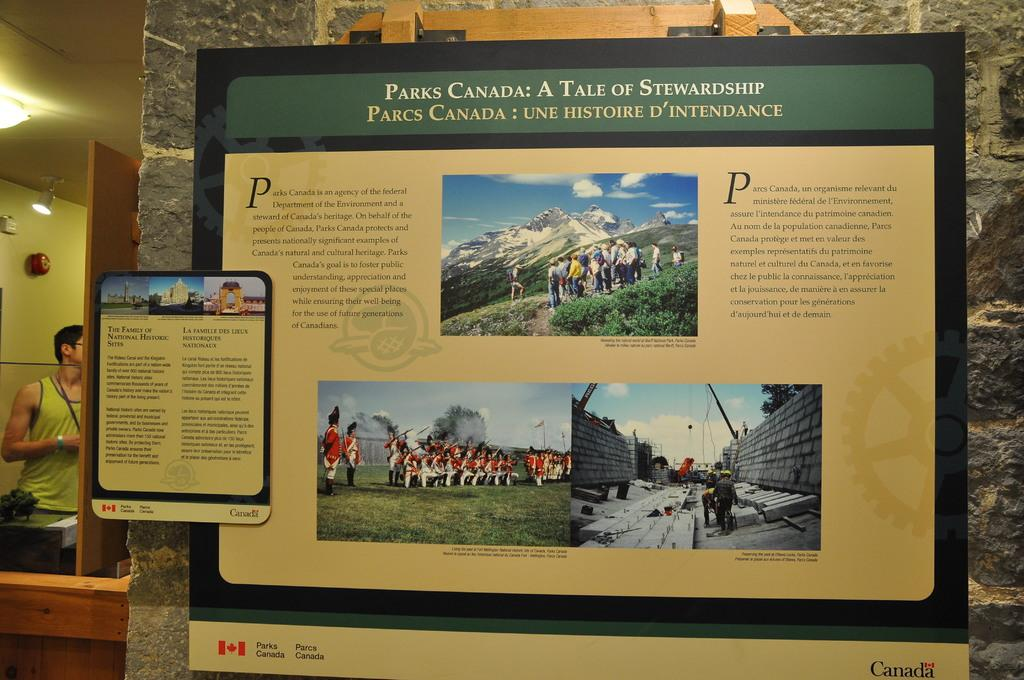<image>
Relay a brief, clear account of the picture shown. An advertisement that says, Parks Canada: A Tale of Stewardship at the top. 